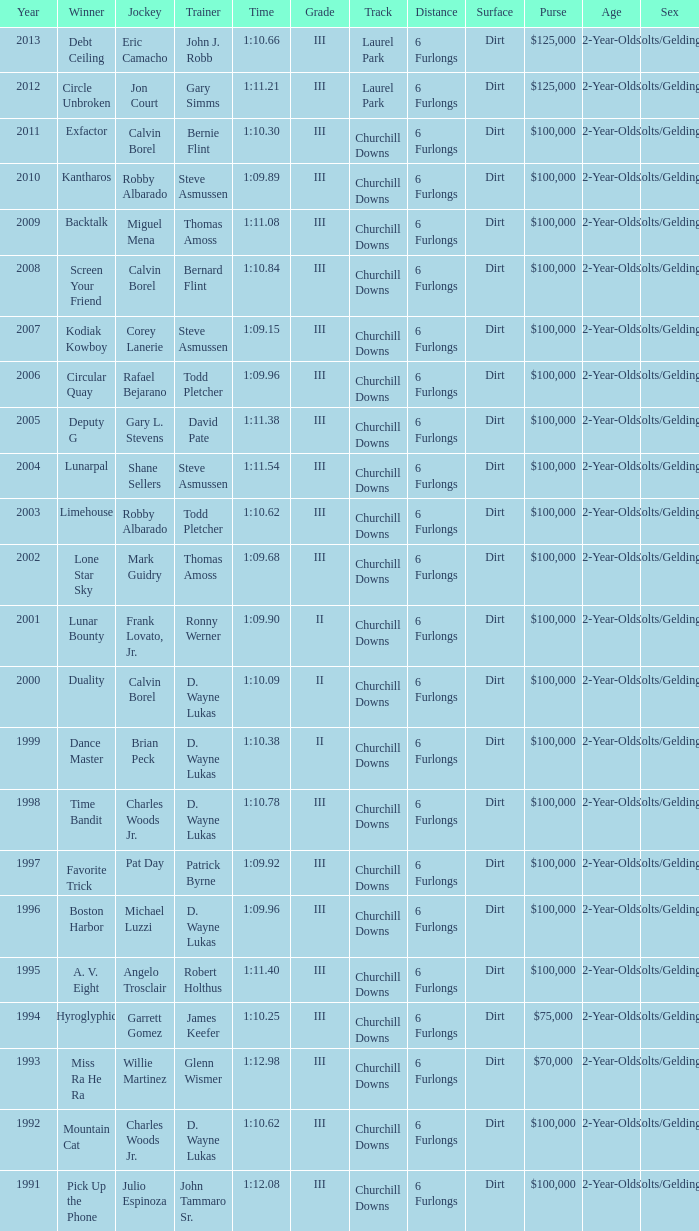Which trainer had a time of 1:10.09 with a year less than 2009? D. Wayne Lukas. Could you help me parse every detail presented in this table? {'header': ['Year', 'Winner', 'Jockey', 'Trainer', 'Time', 'Grade', 'Track', 'Distance', 'Surface', 'Purse', 'Age', 'Sex'], 'rows': [['2013', 'Debt Ceiling', 'Eric Camacho', 'John J. Robb', '1:10.66', 'III', 'Laurel Park', '6 Furlongs', 'Dirt', '$125,000', '2-Year-Olds', 'Colts/Geldings'], ['2012', 'Circle Unbroken', 'Jon Court', 'Gary Simms', '1:11.21', 'III', 'Laurel Park', '6 Furlongs', 'Dirt', '$125,000', '2-Year-Olds', 'Colts/Geldings'], ['2011', 'Exfactor', 'Calvin Borel', 'Bernie Flint', '1:10.30', 'III', 'Churchill Downs', '6 Furlongs', 'Dirt', '$100,000', '2-Year-Olds', 'Colts/Geldings'], ['2010', 'Kantharos', 'Robby Albarado', 'Steve Asmussen', '1:09.89', 'III', 'Churchill Downs', '6 Furlongs', 'Dirt', '$100,000', '2-Year-Olds', 'Colts/Geldings'], ['2009', 'Backtalk', 'Miguel Mena', 'Thomas Amoss', '1:11.08', 'III', 'Churchill Downs', '6 Furlongs', 'Dirt', '$100,000', '2-Year-Olds', 'Colts/Geldings'], ['2008', 'Screen Your Friend', 'Calvin Borel', 'Bernard Flint', '1:10.84', 'III', 'Churchill Downs', '6 Furlongs', 'Dirt', '$100,000', '2-Year-Olds', 'Colts/Geldings'], ['2007', 'Kodiak Kowboy', 'Corey Lanerie', 'Steve Asmussen', '1:09.15', 'III', 'Churchill Downs', '6 Furlongs', 'Dirt', '$100,000', '2-Year-Olds', 'Colts/Geldings'], ['2006', 'Circular Quay', 'Rafael Bejarano', 'Todd Pletcher', '1:09.96', 'III', 'Churchill Downs', '6 Furlongs', 'Dirt', '$100,000', '2-Year-Olds', 'Colts/Geldings'], ['2005', 'Deputy G', 'Gary L. Stevens', 'David Pate', '1:11.38', 'III', 'Churchill Downs', '6 Furlongs', 'Dirt', '$100,000', '2-Year-Olds', 'Colts/Geldings'], ['2004', 'Lunarpal', 'Shane Sellers', 'Steve Asmussen', '1:11.54', 'III', 'Churchill Downs', '6 Furlongs', 'Dirt', '$100,000', '2-Year-Olds', 'Colts/Geldings'], ['2003', 'Limehouse', 'Robby Albarado', 'Todd Pletcher', '1:10.62', 'III', 'Churchill Downs', '6 Furlongs', 'Dirt', '$100,000', '2-Year-Olds', 'Colts/Geldings'], ['2002', 'Lone Star Sky', 'Mark Guidry', 'Thomas Amoss', '1:09.68', 'III', 'Churchill Downs', '6 Furlongs', 'Dirt', '$100,000', '2-Year-Olds', 'Colts/Geldings'], ['2001', 'Lunar Bounty', 'Frank Lovato, Jr.', 'Ronny Werner', '1:09.90', 'II', 'Churchill Downs', '6 Furlongs', 'Dirt', '$100,000', '2-Year-Olds', 'Colts/Geldings'], ['2000', 'Duality', 'Calvin Borel', 'D. Wayne Lukas', '1:10.09', 'II', 'Churchill Downs', '6 Furlongs', 'Dirt', '$100,000', '2-Year-Olds', 'Colts/Geldings'], ['1999', 'Dance Master', 'Brian Peck', 'D. Wayne Lukas', '1:10.38', 'II', 'Churchill Downs', '6 Furlongs', 'Dirt', '$100,000', '2-Year-Olds', 'Colts/Geldings'], ['1998', 'Time Bandit', 'Charles Woods Jr.', 'D. Wayne Lukas', '1:10.78', 'III', 'Churchill Downs', '6 Furlongs', 'Dirt', '$100,000', '2-Year-Olds', 'Colts/Geldings'], ['1997', 'Favorite Trick', 'Pat Day', 'Patrick Byrne', '1:09.92', 'III', 'Churchill Downs', '6 Furlongs', 'Dirt', '$100,000', '2-Year-Olds', 'Colts/Geldings'], ['1996', 'Boston Harbor', 'Michael Luzzi', 'D. Wayne Lukas', '1:09.96', 'III', 'Churchill Downs', '6 Furlongs', 'Dirt', '$100,000', '2-Year-Olds', 'Colts/Geldings'], ['1995', 'A. V. Eight', 'Angelo Trosclair', 'Robert Holthus', '1:11.40', 'III', 'Churchill Downs', '6 Furlongs', 'Dirt', '$100,000', '2-Year-Olds', 'Colts/Geldings'], ['1994', 'Hyroglyphic', 'Garrett Gomez', 'James Keefer', '1:10.25', 'III', 'Churchill Downs', '6 Furlongs', 'Dirt', '$75,000', '2-Year-Olds', 'Colts/Geldings'], ['1993', 'Miss Ra He Ra', 'Willie Martinez', 'Glenn Wismer', '1:12.98', 'III', 'Churchill Downs', '6 Furlongs', 'Dirt', '$70,000', '2-Year-Olds', 'Colts/Geldings'], ['1992', 'Mountain Cat', 'Charles Woods Jr.', 'D. Wayne Lukas', '1:10.62', 'III', 'Churchill Downs', '6 Furlongs', 'Dirt', '$100,000', '2-Year-Olds', 'Colts/Geldings'], ['1991', 'Pick Up the Phone', 'Julio Espinoza', 'John Tammaro Sr.', '1:12.08', 'III', 'Churchill Downs', '6 Furlongs', 'Dirt', '$100,000', '2-Year-Olds', 'Colts/Geldings']]} 